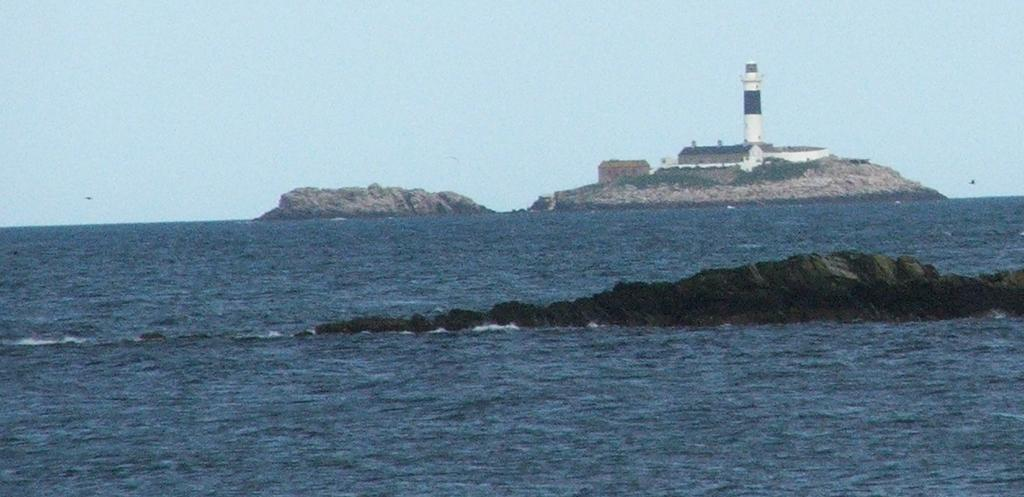What is located at the front of the image? There is water in the front of the image. What can be seen in the background of the image? There are buildings and a lighthouse in the background of the image. What is visible in the sky in the image? The sky is visible in the background of the image. Where is the jar of jam stored in the image? There is no jar of jam present in the image. What type of birth can be seen taking place in the image? There is no birth depicted in the image; it features water, buildings, a lighthouse, and the sky. 